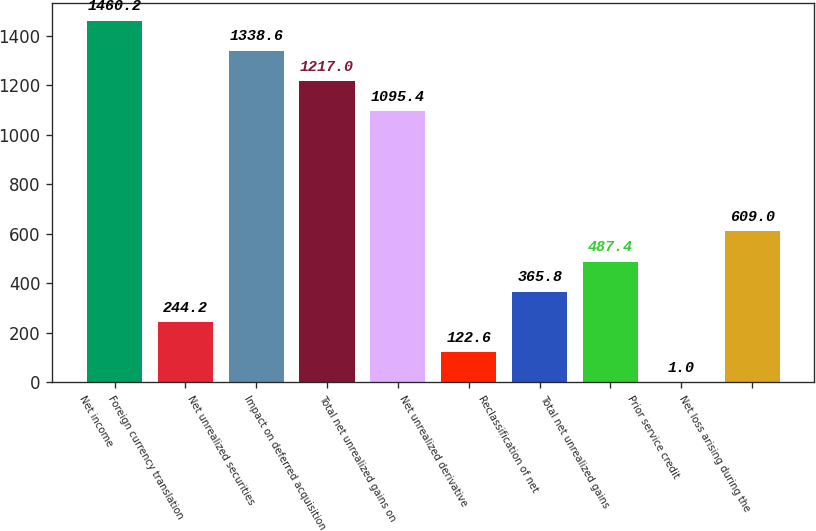Convert chart. <chart><loc_0><loc_0><loc_500><loc_500><bar_chart><fcel>Net income<fcel>Foreign currency translation<fcel>Net unrealized securities<fcel>Impact on deferred acquisition<fcel>Total net unrealized gains on<fcel>Net unrealized derivative<fcel>Reclassification of net<fcel>Total net unrealized gains<fcel>Prior service credit<fcel>Net loss arising during the<nl><fcel>1460.2<fcel>244.2<fcel>1338.6<fcel>1217<fcel>1095.4<fcel>122.6<fcel>365.8<fcel>487.4<fcel>1<fcel>609<nl></chart> 